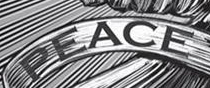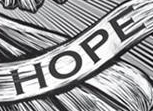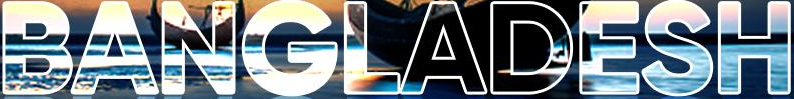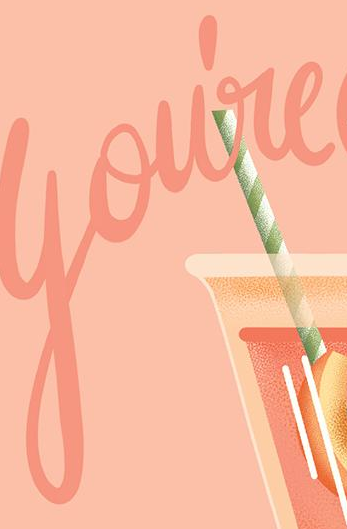Transcribe the words shown in these images in order, separated by a semicolon. PEACE; HOPE; BANGLADESH; You're 